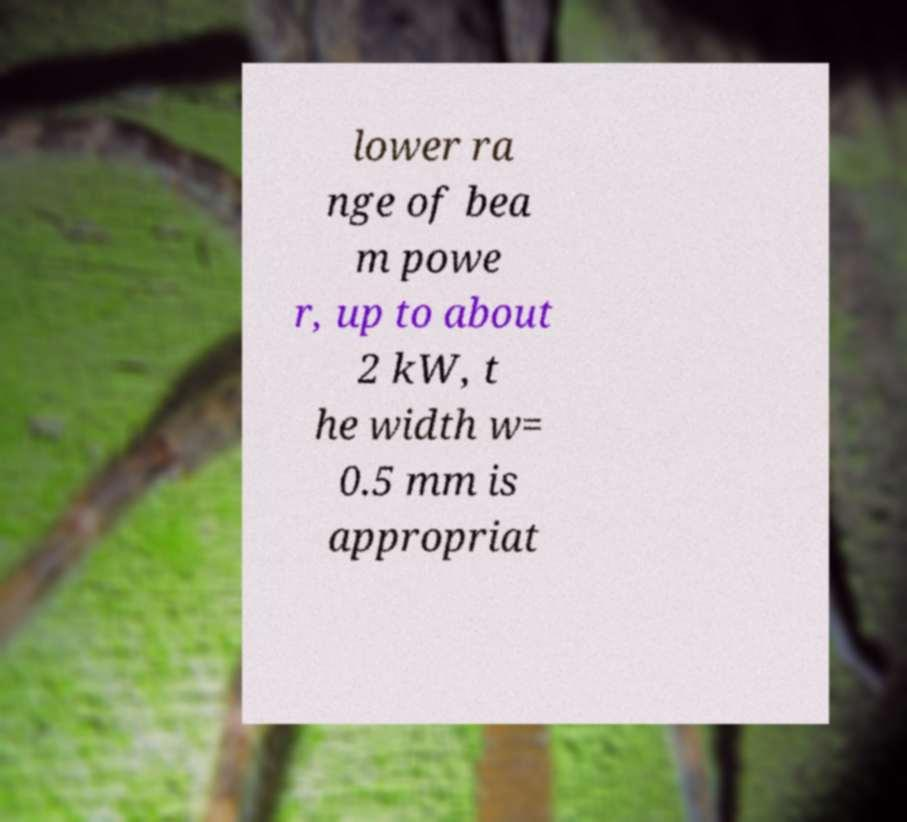Could you extract and type out the text from this image? lower ra nge of bea m powe r, up to about 2 kW, t he width w= 0.5 mm is appropriat 